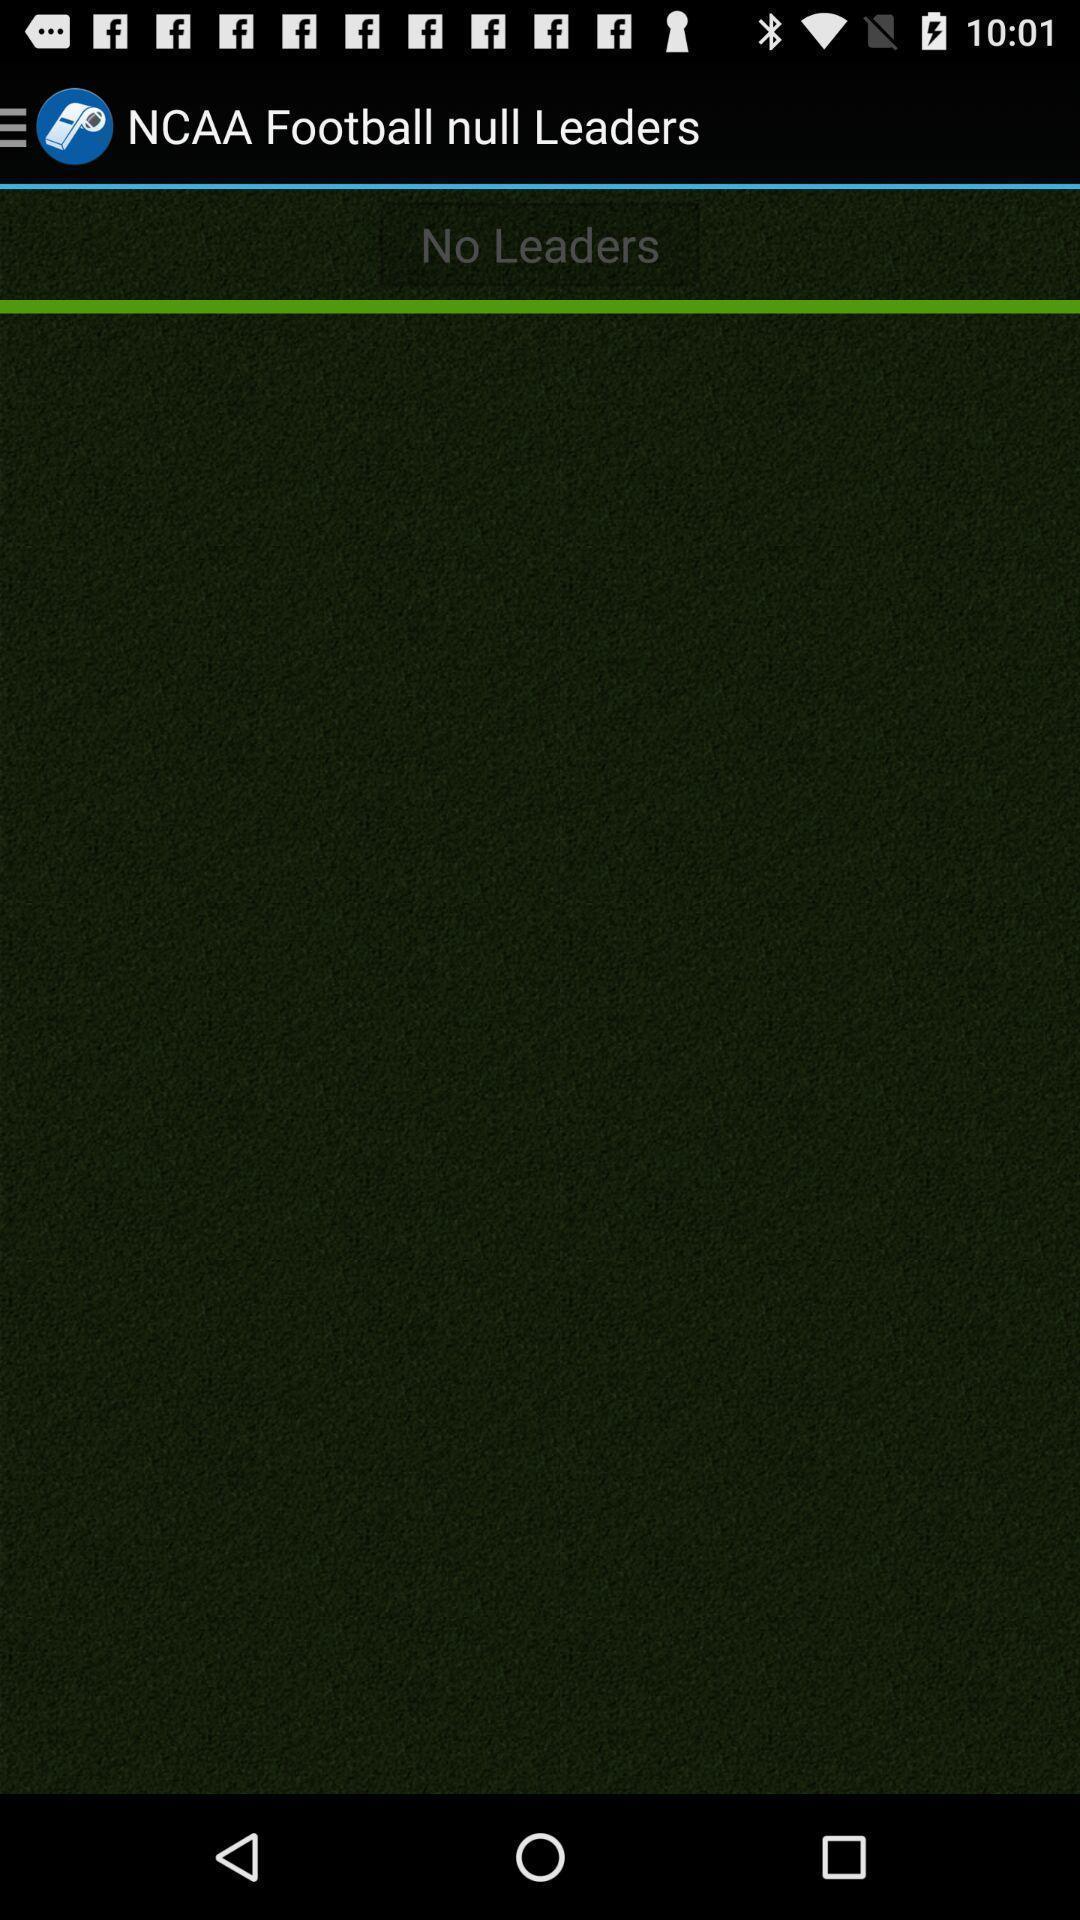Describe the key features of this screenshot. Screen displaying football null leaders page. 